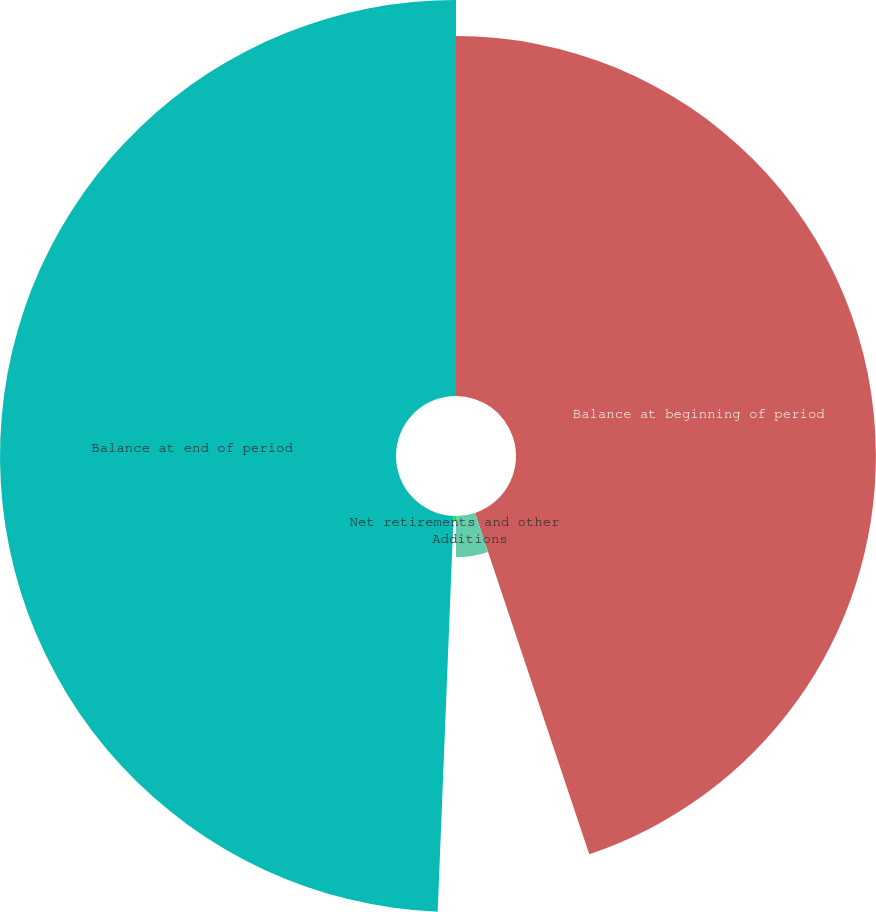Convert chart to OTSL. <chart><loc_0><loc_0><loc_500><loc_500><pie_chart><fcel>Balance at beginning of period<fcel>Additions<fcel>Net retirements and other<fcel>Balance at end of period<nl><fcel>44.86%<fcel>5.14%<fcel>0.64%<fcel>49.36%<nl></chart> 